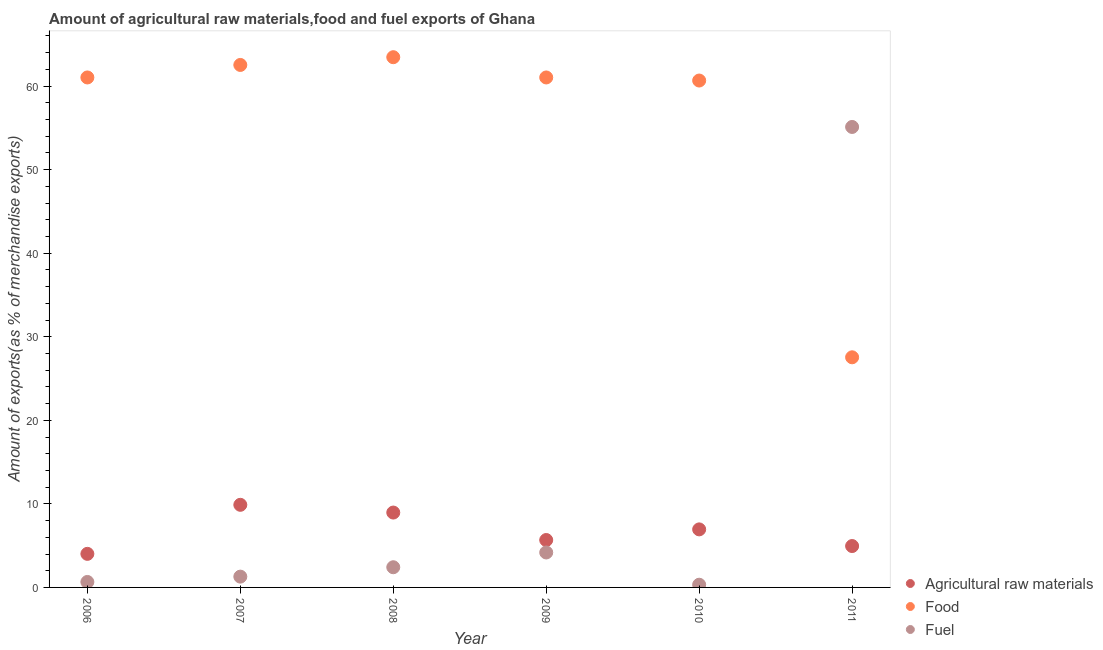What is the percentage of food exports in 2007?
Keep it short and to the point. 62.53. Across all years, what is the maximum percentage of raw materials exports?
Offer a terse response. 9.89. Across all years, what is the minimum percentage of food exports?
Your response must be concise. 27.54. In which year was the percentage of food exports minimum?
Offer a terse response. 2011. What is the total percentage of food exports in the graph?
Offer a very short reply. 336.28. What is the difference between the percentage of fuel exports in 2006 and that in 2011?
Provide a short and direct response. -54.46. What is the difference between the percentage of fuel exports in 2011 and the percentage of food exports in 2006?
Provide a short and direct response. -5.92. What is the average percentage of fuel exports per year?
Keep it short and to the point. 10.66. In the year 2011, what is the difference between the percentage of raw materials exports and percentage of food exports?
Provide a succinct answer. -22.59. What is the ratio of the percentage of food exports in 2008 to that in 2010?
Keep it short and to the point. 1.05. What is the difference between the highest and the second highest percentage of raw materials exports?
Ensure brevity in your answer.  0.93. What is the difference between the highest and the lowest percentage of raw materials exports?
Provide a short and direct response. 5.87. Is the sum of the percentage of raw materials exports in 2007 and 2009 greater than the maximum percentage of fuel exports across all years?
Keep it short and to the point. No. Does the percentage of food exports monotonically increase over the years?
Provide a succinct answer. No. Is the percentage of food exports strictly greater than the percentage of raw materials exports over the years?
Offer a very short reply. Yes. Is the percentage of fuel exports strictly less than the percentage of raw materials exports over the years?
Make the answer very short. No. How many years are there in the graph?
Your answer should be very brief. 6. Does the graph contain any zero values?
Your response must be concise. No. Does the graph contain grids?
Your response must be concise. No. Where does the legend appear in the graph?
Provide a short and direct response. Bottom right. How are the legend labels stacked?
Offer a very short reply. Vertical. What is the title of the graph?
Offer a very short reply. Amount of agricultural raw materials,food and fuel exports of Ghana. Does "Maunufacturing" appear as one of the legend labels in the graph?
Your response must be concise. No. What is the label or title of the X-axis?
Your answer should be very brief. Year. What is the label or title of the Y-axis?
Your answer should be very brief. Amount of exports(as % of merchandise exports). What is the Amount of exports(as % of merchandise exports) of Agricultural raw materials in 2006?
Ensure brevity in your answer.  4.02. What is the Amount of exports(as % of merchandise exports) of Food in 2006?
Ensure brevity in your answer.  61.04. What is the Amount of exports(as % of merchandise exports) of Fuel in 2006?
Your answer should be very brief. 0.65. What is the Amount of exports(as % of merchandise exports) in Agricultural raw materials in 2007?
Offer a very short reply. 9.89. What is the Amount of exports(as % of merchandise exports) of Food in 2007?
Make the answer very short. 62.53. What is the Amount of exports(as % of merchandise exports) in Fuel in 2007?
Your answer should be very brief. 1.29. What is the Amount of exports(as % of merchandise exports) of Agricultural raw materials in 2008?
Make the answer very short. 8.96. What is the Amount of exports(as % of merchandise exports) of Food in 2008?
Provide a short and direct response. 63.46. What is the Amount of exports(as % of merchandise exports) of Fuel in 2008?
Offer a terse response. 2.42. What is the Amount of exports(as % of merchandise exports) of Agricultural raw materials in 2009?
Ensure brevity in your answer.  5.67. What is the Amount of exports(as % of merchandise exports) in Food in 2009?
Your answer should be compact. 61.04. What is the Amount of exports(as % of merchandise exports) in Fuel in 2009?
Provide a succinct answer. 4.18. What is the Amount of exports(as % of merchandise exports) in Agricultural raw materials in 2010?
Provide a short and direct response. 6.95. What is the Amount of exports(as % of merchandise exports) of Food in 2010?
Offer a terse response. 60.67. What is the Amount of exports(as % of merchandise exports) in Fuel in 2010?
Your answer should be very brief. 0.32. What is the Amount of exports(as % of merchandise exports) in Agricultural raw materials in 2011?
Offer a very short reply. 4.95. What is the Amount of exports(as % of merchandise exports) of Food in 2011?
Give a very brief answer. 27.54. What is the Amount of exports(as % of merchandise exports) of Fuel in 2011?
Make the answer very short. 55.11. Across all years, what is the maximum Amount of exports(as % of merchandise exports) of Agricultural raw materials?
Make the answer very short. 9.89. Across all years, what is the maximum Amount of exports(as % of merchandise exports) in Food?
Provide a succinct answer. 63.46. Across all years, what is the maximum Amount of exports(as % of merchandise exports) of Fuel?
Your answer should be compact. 55.11. Across all years, what is the minimum Amount of exports(as % of merchandise exports) in Agricultural raw materials?
Provide a short and direct response. 4.02. Across all years, what is the minimum Amount of exports(as % of merchandise exports) of Food?
Make the answer very short. 27.54. Across all years, what is the minimum Amount of exports(as % of merchandise exports) of Fuel?
Give a very brief answer. 0.32. What is the total Amount of exports(as % of merchandise exports) in Agricultural raw materials in the graph?
Ensure brevity in your answer.  40.44. What is the total Amount of exports(as % of merchandise exports) in Food in the graph?
Ensure brevity in your answer.  336.28. What is the total Amount of exports(as % of merchandise exports) of Fuel in the graph?
Your answer should be very brief. 63.98. What is the difference between the Amount of exports(as % of merchandise exports) in Agricultural raw materials in 2006 and that in 2007?
Offer a very short reply. -5.87. What is the difference between the Amount of exports(as % of merchandise exports) of Food in 2006 and that in 2007?
Make the answer very short. -1.5. What is the difference between the Amount of exports(as % of merchandise exports) in Fuel in 2006 and that in 2007?
Ensure brevity in your answer.  -0.64. What is the difference between the Amount of exports(as % of merchandise exports) in Agricultural raw materials in 2006 and that in 2008?
Your answer should be very brief. -4.94. What is the difference between the Amount of exports(as % of merchandise exports) in Food in 2006 and that in 2008?
Provide a succinct answer. -2.42. What is the difference between the Amount of exports(as % of merchandise exports) of Fuel in 2006 and that in 2008?
Your response must be concise. -1.76. What is the difference between the Amount of exports(as % of merchandise exports) in Agricultural raw materials in 2006 and that in 2009?
Offer a terse response. -1.66. What is the difference between the Amount of exports(as % of merchandise exports) in Food in 2006 and that in 2009?
Keep it short and to the point. 0. What is the difference between the Amount of exports(as % of merchandise exports) of Fuel in 2006 and that in 2009?
Provide a short and direct response. -3.53. What is the difference between the Amount of exports(as % of merchandise exports) of Agricultural raw materials in 2006 and that in 2010?
Your answer should be very brief. -2.93. What is the difference between the Amount of exports(as % of merchandise exports) of Food in 2006 and that in 2010?
Keep it short and to the point. 0.37. What is the difference between the Amount of exports(as % of merchandise exports) of Fuel in 2006 and that in 2010?
Your answer should be very brief. 0.33. What is the difference between the Amount of exports(as % of merchandise exports) in Agricultural raw materials in 2006 and that in 2011?
Keep it short and to the point. -0.93. What is the difference between the Amount of exports(as % of merchandise exports) in Food in 2006 and that in 2011?
Offer a terse response. 33.49. What is the difference between the Amount of exports(as % of merchandise exports) of Fuel in 2006 and that in 2011?
Provide a succinct answer. -54.46. What is the difference between the Amount of exports(as % of merchandise exports) of Agricultural raw materials in 2007 and that in 2008?
Offer a terse response. 0.93. What is the difference between the Amount of exports(as % of merchandise exports) in Food in 2007 and that in 2008?
Provide a short and direct response. -0.93. What is the difference between the Amount of exports(as % of merchandise exports) of Fuel in 2007 and that in 2008?
Your answer should be compact. -1.12. What is the difference between the Amount of exports(as % of merchandise exports) in Agricultural raw materials in 2007 and that in 2009?
Your answer should be compact. 4.21. What is the difference between the Amount of exports(as % of merchandise exports) of Food in 2007 and that in 2009?
Your answer should be compact. 1.5. What is the difference between the Amount of exports(as % of merchandise exports) in Fuel in 2007 and that in 2009?
Give a very brief answer. -2.89. What is the difference between the Amount of exports(as % of merchandise exports) in Agricultural raw materials in 2007 and that in 2010?
Keep it short and to the point. 2.94. What is the difference between the Amount of exports(as % of merchandise exports) in Food in 2007 and that in 2010?
Your answer should be very brief. 1.87. What is the difference between the Amount of exports(as % of merchandise exports) in Fuel in 2007 and that in 2010?
Make the answer very short. 0.97. What is the difference between the Amount of exports(as % of merchandise exports) in Agricultural raw materials in 2007 and that in 2011?
Your answer should be very brief. 4.93. What is the difference between the Amount of exports(as % of merchandise exports) in Food in 2007 and that in 2011?
Provide a succinct answer. 34.99. What is the difference between the Amount of exports(as % of merchandise exports) in Fuel in 2007 and that in 2011?
Your response must be concise. -53.82. What is the difference between the Amount of exports(as % of merchandise exports) of Agricultural raw materials in 2008 and that in 2009?
Offer a very short reply. 3.29. What is the difference between the Amount of exports(as % of merchandise exports) in Food in 2008 and that in 2009?
Your response must be concise. 2.42. What is the difference between the Amount of exports(as % of merchandise exports) in Fuel in 2008 and that in 2009?
Give a very brief answer. -1.77. What is the difference between the Amount of exports(as % of merchandise exports) of Agricultural raw materials in 2008 and that in 2010?
Your response must be concise. 2.01. What is the difference between the Amount of exports(as % of merchandise exports) of Food in 2008 and that in 2010?
Your answer should be very brief. 2.79. What is the difference between the Amount of exports(as % of merchandise exports) of Fuel in 2008 and that in 2010?
Offer a very short reply. 2.09. What is the difference between the Amount of exports(as % of merchandise exports) in Agricultural raw materials in 2008 and that in 2011?
Your answer should be compact. 4.01. What is the difference between the Amount of exports(as % of merchandise exports) of Food in 2008 and that in 2011?
Give a very brief answer. 35.92. What is the difference between the Amount of exports(as % of merchandise exports) of Fuel in 2008 and that in 2011?
Provide a succinct answer. -52.7. What is the difference between the Amount of exports(as % of merchandise exports) of Agricultural raw materials in 2009 and that in 2010?
Your answer should be very brief. -1.27. What is the difference between the Amount of exports(as % of merchandise exports) of Food in 2009 and that in 2010?
Offer a terse response. 0.37. What is the difference between the Amount of exports(as % of merchandise exports) in Fuel in 2009 and that in 2010?
Provide a succinct answer. 3.86. What is the difference between the Amount of exports(as % of merchandise exports) of Agricultural raw materials in 2009 and that in 2011?
Provide a short and direct response. 0.72. What is the difference between the Amount of exports(as % of merchandise exports) in Food in 2009 and that in 2011?
Your answer should be compact. 33.49. What is the difference between the Amount of exports(as % of merchandise exports) of Fuel in 2009 and that in 2011?
Give a very brief answer. -50.93. What is the difference between the Amount of exports(as % of merchandise exports) in Agricultural raw materials in 2010 and that in 2011?
Offer a very short reply. 1.99. What is the difference between the Amount of exports(as % of merchandise exports) of Food in 2010 and that in 2011?
Give a very brief answer. 33.13. What is the difference between the Amount of exports(as % of merchandise exports) of Fuel in 2010 and that in 2011?
Give a very brief answer. -54.79. What is the difference between the Amount of exports(as % of merchandise exports) in Agricultural raw materials in 2006 and the Amount of exports(as % of merchandise exports) in Food in 2007?
Provide a succinct answer. -58.52. What is the difference between the Amount of exports(as % of merchandise exports) of Agricultural raw materials in 2006 and the Amount of exports(as % of merchandise exports) of Fuel in 2007?
Provide a succinct answer. 2.73. What is the difference between the Amount of exports(as % of merchandise exports) in Food in 2006 and the Amount of exports(as % of merchandise exports) in Fuel in 2007?
Keep it short and to the point. 59.74. What is the difference between the Amount of exports(as % of merchandise exports) of Agricultural raw materials in 2006 and the Amount of exports(as % of merchandise exports) of Food in 2008?
Offer a very short reply. -59.44. What is the difference between the Amount of exports(as % of merchandise exports) in Agricultural raw materials in 2006 and the Amount of exports(as % of merchandise exports) in Fuel in 2008?
Ensure brevity in your answer.  1.6. What is the difference between the Amount of exports(as % of merchandise exports) of Food in 2006 and the Amount of exports(as % of merchandise exports) of Fuel in 2008?
Offer a terse response. 58.62. What is the difference between the Amount of exports(as % of merchandise exports) in Agricultural raw materials in 2006 and the Amount of exports(as % of merchandise exports) in Food in 2009?
Your answer should be compact. -57.02. What is the difference between the Amount of exports(as % of merchandise exports) in Agricultural raw materials in 2006 and the Amount of exports(as % of merchandise exports) in Fuel in 2009?
Your answer should be very brief. -0.17. What is the difference between the Amount of exports(as % of merchandise exports) in Food in 2006 and the Amount of exports(as % of merchandise exports) in Fuel in 2009?
Make the answer very short. 56.85. What is the difference between the Amount of exports(as % of merchandise exports) in Agricultural raw materials in 2006 and the Amount of exports(as % of merchandise exports) in Food in 2010?
Make the answer very short. -56.65. What is the difference between the Amount of exports(as % of merchandise exports) in Agricultural raw materials in 2006 and the Amount of exports(as % of merchandise exports) in Fuel in 2010?
Give a very brief answer. 3.69. What is the difference between the Amount of exports(as % of merchandise exports) of Food in 2006 and the Amount of exports(as % of merchandise exports) of Fuel in 2010?
Your answer should be compact. 60.71. What is the difference between the Amount of exports(as % of merchandise exports) in Agricultural raw materials in 2006 and the Amount of exports(as % of merchandise exports) in Food in 2011?
Give a very brief answer. -23.53. What is the difference between the Amount of exports(as % of merchandise exports) in Agricultural raw materials in 2006 and the Amount of exports(as % of merchandise exports) in Fuel in 2011?
Give a very brief answer. -51.09. What is the difference between the Amount of exports(as % of merchandise exports) in Food in 2006 and the Amount of exports(as % of merchandise exports) in Fuel in 2011?
Provide a succinct answer. 5.92. What is the difference between the Amount of exports(as % of merchandise exports) in Agricultural raw materials in 2007 and the Amount of exports(as % of merchandise exports) in Food in 2008?
Keep it short and to the point. -53.57. What is the difference between the Amount of exports(as % of merchandise exports) of Agricultural raw materials in 2007 and the Amount of exports(as % of merchandise exports) of Fuel in 2008?
Keep it short and to the point. 7.47. What is the difference between the Amount of exports(as % of merchandise exports) of Food in 2007 and the Amount of exports(as % of merchandise exports) of Fuel in 2008?
Offer a very short reply. 60.12. What is the difference between the Amount of exports(as % of merchandise exports) in Agricultural raw materials in 2007 and the Amount of exports(as % of merchandise exports) in Food in 2009?
Your answer should be very brief. -51.15. What is the difference between the Amount of exports(as % of merchandise exports) of Agricultural raw materials in 2007 and the Amount of exports(as % of merchandise exports) of Fuel in 2009?
Provide a short and direct response. 5.7. What is the difference between the Amount of exports(as % of merchandise exports) in Food in 2007 and the Amount of exports(as % of merchandise exports) in Fuel in 2009?
Offer a very short reply. 58.35. What is the difference between the Amount of exports(as % of merchandise exports) in Agricultural raw materials in 2007 and the Amount of exports(as % of merchandise exports) in Food in 2010?
Provide a short and direct response. -50.78. What is the difference between the Amount of exports(as % of merchandise exports) in Agricultural raw materials in 2007 and the Amount of exports(as % of merchandise exports) in Fuel in 2010?
Offer a terse response. 9.56. What is the difference between the Amount of exports(as % of merchandise exports) of Food in 2007 and the Amount of exports(as % of merchandise exports) of Fuel in 2010?
Provide a succinct answer. 62.21. What is the difference between the Amount of exports(as % of merchandise exports) of Agricultural raw materials in 2007 and the Amount of exports(as % of merchandise exports) of Food in 2011?
Your response must be concise. -17.66. What is the difference between the Amount of exports(as % of merchandise exports) of Agricultural raw materials in 2007 and the Amount of exports(as % of merchandise exports) of Fuel in 2011?
Keep it short and to the point. -45.23. What is the difference between the Amount of exports(as % of merchandise exports) of Food in 2007 and the Amount of exports(as % of merchandise exports) of Fuel in 2011?
Give a very brief answer. 7.42. What is the difference between the Amount of exports(as % of merchandise exports) in Agricultural raw materials in 2008 and the Amount of exports(as % of merchandise exports) in Food in 2009?
Keep it short and to the point. -52.08. What is the difference between the Amount of exports(as % of merchandise exports) in Agricultural raw materials in 2008 and the Amount of exports(as % of merchandise exports) in Fuel in 2009?
Your response must be concise. 4.78. What is the difference between the Amount of exports(as % of merchandise exports) in Food in 2008 and the Amount of exports(as % of merchandise exports) in Fuel in 2009?
Provide a succinct answer. 59.28. What is the difference between the Amount of exports(as % of merchandise exports) of Agricultural raw materials in 2008 and the Amount of exports(as % of merchandise exports) of Food in 2010?
Your answer should be compact. -51.71. What is the difference between the Amount of exports(as % of merchandise exports) in Agricultural raw materials in 2008 and the Amount of exports(as % of merchandise exports) in Fuel in 2010?
Keep it short and to the point. 8.64. What is the difference between the Amount of exports(as % of merchandise exports) in Food in 2008 and the Amount of exports(as % of merchandise exports) in Fuel in 2010?
Your answer should be very brief. 63.14. What is the difference between the Amount of exports(as % of merchandise exports) of Agricultural raw materials in 2008 and the Amount of exports(as % of merchandise exports) of Food in 2011?
Provide a succinct answer. -18.58. What is the difference between the Amount of exports(as % of merchandise exports) in Agricultural raw materials in 2008 and the Amount of exports(as % of merchandise exports) in Fuel in 2011?
Your response must be concise. -46.15. What is the difference between the Amount of exports(as % of merchandise exports) of Food in 2008 and the Amount of exports(as % of merchandise exports) of Fuel in 2011?
Offer a very short reply. 8.35. What is the difference between the Amount of exports(as % of merchandise exports) in Agricultural raw materials in 2009 and the Amount of exports(as % of merchandise exports) in Food in 2010?
Your response must be concise. -54.99. What is the difference between the Amount of exports(as % of merchandise exports) in Agricultural raw materials in 2009 and the Amount of exports(as % of merchandise exports) in Fuel in 2010?
Give a very brief answer. 5.35. What is the difference between the Amount of exports(as % of merchandise exports) of Food in 2009 and the Amount of exports(as % of merchandise exports) of Fuel in 2010?
Make the answer very short. 60.71. What is the difference between the Amount of exports(as % of merchandise exports) of Agricultural raw materials in 2009 and the Amount of exports(as % of merchandise exports) of Food in 2011?
Give a very brief answer. -21.87. What is the difference between the Amount of exports(as % of merchandise exports) of Agricultural raw materials in 2009 and the Amount of exports(as % of merchandise exports) of Fuel in 2011?
Provide a succinct answer. -49.44. What is the difference between the Amount of exports(as % of merchandise exports) of Food in 2009 and the Amount of exports(as % of merchandise exports) of Fuel in 2011?
Ensure brevity in your answer.  5.92. What is the difference between the Amount of exports(as % of merchandise exports) in Agricultural raw materials in 2010 and the Amount of exports(as % of merchandise exports) in Food in 2011?
Provide a short and direct response. -20.6. What is the difference between the Amount of exports(as % of merchandise exports) of Agricultural raw materials in 2010 and the Amount of exports(as % of merchandise exports) of Fuel in 2011?
Give a very brief answer. -48.17. What is the difference between the Amount of exports(as % of merchandise exports) in Food in 2010 and the Amount of exports(as % of merchandise exports) in Fuel in 2011?
Make the answer very short. 5.56. What is the average Amount of exports(as % of merchandise exports) of Agricultural raw materials per year?
Provide a short and direct response. 6.74. What is the average Amount of exports(as % of merchandise exports) of Food per year?
Offer a terse response. 56.05. What is the average Amount of exports(as % of merchandise exports) of Fuel per year?
Offer a very short reply. 10.66. In the year 2006, what is the difference between the Amount of exports(as % of merchandise exports) in Agricultural raw materials and Amount of exports(as % of merchandise exports) in Food?
Provide a short and direct response. -57.02. In the year 2006, what is the difference between the Amount of exports(as % of merchandise exports) of Agricultural raw materials and Amount of exports(as % of merchandise exports) of Fuel?
Ensure brevity in your answer.  3.36. In the year 2006, what is the difference between the Amount of exports(as % of merchandise exports) of Food and Amount of exports(as % of merchandise exports) of Fuel?
Your answer should be very brief. 60.38. In the year 2007, what is the difference between the Amount of exports(as % of merchandise exports) of Agricultural raw materials and Amount of exports(as % of merchandise exports) of Food?
Your answer should be very brief. -52.65. In the year 2007, what is the difference between the Amount of exports(as % of merchandise exports) of Agricultural raw materials and Amount of exports(as % of merchandise exports) of Fuel?
Your answer should be compact. 8.6. In the year 2007, what is the difference between the Amount of exports(as % of merchandise exports) of Food and Amount of exports(as % of merchandise exports) of Fuel?
Your answer should be very brief. 61.24. In the year 2008, what is the difference between the Amount of exports(as % of merchandise exports) of Agricultural raw materials and Amount of exports(as % of merchandise exports) of Food?
Make the answer very short. -54.5. In the year 2008, what is the difference between the Amount of exports(as % of merchandise exports) in Agricultural raw materials and Amount of exports(as % of merchandise exports) in Fuel?
Give a very brief answer. 6.55. In the year 2008, what is the difference between the Amount of exports(as % of merchandise exports) of Food and Amount of exports(as % of merchandise exports) of Fuel?
Offer a very short reply. 61.05. In the year 2009, what is the difference between the Amount of exports(as % of merchandise exports) in Agricultural raw materials and Amount of exports(as % of merchandise exports) in Food?
Give a very brief answer. -55.36. In the year 2009, what is the difference between the Amount of exports(as % of merchandise exports) of Agricultural raw materials and Amount of exports(as % of merchandise exports) of Fuel?
Your answer should be very brief. 1.49. In the year 2009, what is the difference between the Amount of exports(as % of merchandise exports) of Food and Amount of exports(as % of merchandise exports) of Fuel?
Your answer should be compact. 56.85. In the year 2010, what is the difference between the Amount of exports(as % of merchandise exports) of Agricultural raw materials and Amount of exports(as % of merchandise exports) of Food?
Keep it short and to the point. -53.72. In the year 2010, what is the difference between the Amount of exports(as % of merchandise exports) in Agricultural raw materials and Amount of exports(as % of merchandise exports) in Fuel?
Offer a terse response. 6.62. In the year 2010, what is the difference between the Amount of exports(as % of merchandise exports) of Food and Amount of exports(as % of merchandise exports) of Fuel?
Offer a terse response. 60.34. In the year 2011, what is the difference between the Amount of exports(as % of merchandise exports) of Agricultural raw materials and Amount of exports(as % of merchandise exports) of Food?
Your answer should be compact. -22.59. In the year 2011, what is the difference between the Amount of exports(as % of merchandise exports) in Agricultural raw materials and Amount of exports(as % of merchandise exports) in Fuel?
Your answer should be very brief. -50.16. In the year 2011, what is the difference between the Amount of exports(as % of merchandise exports) in Food and Amount of exports(as % of merchandise exports) in Fuel?
Make the answer very short. -27.57. What is the ratio of the Amount of exports(as % of merchandise exports) of Agricultural raw materials in 2006 to that in 2007?
Provide a succinct answer. 0.41. What is the ratio of the Amount of exports(as % of merchandise exports) in Food in 2006 to that in 2007?
Keep it short and to the point. 0.98. What is the ratio of the Amount of exports(as % of merchandise exports) of Fuel in 2006 to that in 2007?
Your answer should be compact. 0.51. What is the ratio of the Amount of exports(as % of merchandise exports) of Agricultural raw materials in 2006 to that in 2008?
Offer a very short reply. 0.45. What is the ratio of the Amount of exports(as % of merchandise exports) in Food in 2006 to that in 2008?
Keep it short and to the point. 0.96. What is the ratio of the Amount of exports(as % of merchandise exports) of Fuel in 2006 to that in 2008?
Your response must be concise. 0.27. What is the ratio of the Amount of exports(as % of merchandise exports) in Agricultural raw materials in 2006 to that in 2009?
Give a very brief answer. 0.71. What is the ratio of the Amount of exports(as % of merchandise exports) in Food in 2006 to that in 2009?
Provide a short and direct response. 1. What is the ratio of the Amount of exports(as % of merchandise exports) in Fuel in 2006 to that in 2009?
Your response must be concise. 0.16. What is the ratio of the Amount of exports(as % of merchandise exports) of Agricultural raw materials in 2006 to that in 2010?
Make the answer very short. 0.58. What is the ratio of the Amount of exports(as % of merchandise exports) in Fuel in 2006 to that in 2010?
Offer a terse response. 2.02. What is the ratio of the Amount of exports(as % of merchandise exports) in Agricultural raw materials in 2006 to that in 2011?
Offer a terse response. 0.81. What is the ratio of the Amount of exports(as % of merchandise exports) of Food in 2006 to that in 2011?
Your answer should be compact. 2.22. What is the ratio of the Amount of exports(as % of merchandise exports) of Fuel in 2006 to that in 2011?
Make the answer very short. 0.01. What is the ratio of the Amount of exports(as % of merchandise exports) of Agricultural raw materials in 2007 to that in 2008?
Your response must be concise. 1.1. What is the ratio of the Amount of exports(as % of merchandise exports) in Food in 2007 to that in 2008?
Keep it short and to the point. 0.99. What is the ratio of the Amount of exports(as % of merchandise exports) of Fuel in 2007 to that in 2008?
Your answer should be compact. 0.54. What is the ratio of the Amount of exports(as % of merchandise exports) in Agricultural raw materials in 2007 to that in 2009?
Your answer should be compact. 1.74. What is the ratio of the Amount of exports(as % of merchandise exports) in Food in 2007 to that in 2009?
Your answer should be compact. 1.02. What is the ratio of the Amount of exports(as % of merchandise exports) of Fuel in 2007 to that in 2009?
Provide a short and direct response. 0.31. What is the ratio of the Amount of exports(as % of merchandise exports) in Agricultural raw materials in 2007 to that in 2010?
Provide a short and direct response. 1.42. What is the ratio of the Amount of exports(as % of merchandise exports) in Food in 2007 to that in 2010?
Your answer should be compact. 1.03. What is the ratio of the Amount of exports(as % of merchandise exports) of Fuel in 2007 to that in 2010?
Provide a short and direct response. 3.99. What is the ratio of the Amount of exports(as % of merchandise exports) of Agricultural raw materials in 2007 to that in 2011?
Make the answer very short. 2. What is the ratio of the Amount of exports(as % of merchandise exports) of Food in 2007 to that in 2011?
Your response must be concise. 2.27. What is the ratio of the Amount of exports(as % of merchandise exports) in Fuel in 2007 to that in 2011?
Provide a succinct answer. 0.02. What is the ratio of the Amount of exports(as % of merchandise exports) of Agricultural raw materials in 2008 to that in 2009?
Your answer should be very brief. 1.58. What is the ratio of the Amount of exports(as % of merchandise exports) in Food in 2008 to that in 2009?
Keep it short and to the point. 1.04. What is the ratio of the Amount of exports(as % of merchandise exports) of Fuel in 2008 to that in 2009?
Your answer should be compact. 0.58. What is the ratio of the Amount of exports(as % of merchandise exports) in Agricultural raw materials in 2008 to that in 2010?
Provide a succinct answer. 1.29. What is the ratio of the Amount of exports(as % of merchandise exports) of Food in 2008 to that in 2010?
Keep it short and to the point. 1.05. What is the ratio of the Amount of exports(as % of merchandise exports) in Fuel in 2008 to that in 2010?
Offer a very short reply. 7.47. What is the ratio of the Amount of exports(as % of merchandise exports) of Agricultural raw materials in 2008 to that in 2011?
Offer a very short reply. 1.81. What is the ratio of the Amount of exports(as % of merchandise exports) of Food in 2008 to that in 2011?
Offer a very short reply. 2.3. What is the ratio of the Amount of exports(as % of merchandise exports) in Fuel in 2008 to that in 2011?
Give a very brief answer. 0.04. What is the ratio of the Amount of exports(as % of merchandise exports) in Agricultural raw materials in 2009 to that in 2010?
Provide a succinct answer. 0.82. What is the ratio of the Amount of exports(as % of merchandise exports) in Fuel in 2009 to that in 2010?
Make the answer very short. 12.93. What is the ratio of the Amount of exports(as % of merchandise exports) of Agricultural raw materials in 2009 to that in 2011?
Provide a succinct answer. 1.15. What is the ratio of the Amount of exports(as % of merchandise exports) in Food in 2009 to that in 2011?
Your answer should be compact. 2.22. What is the ratio of the Amount of exports(as % of merchandise exports) in Fuel in 2009 to that in 2011?
Provide a succinct answer. 0.08. What is the ratio of the Amount of exports(as % of merchandise exports) in Agricultural raw materials in 2010 to that in 2011?
Your answer should be very brief. 1.4. What is the ratio of the Amount of exports(as % of merchandise exports) of Food in 2010 to that in 2011?
Keep it short and to the point. 2.2. What is the ratio of the Amount of exports(as % of merchandise exports) of Fuel in 2010 to that in 2011?
Your answer should be compact. 0.01. What is the difference between the highest and the second highest Amount of exports(as % of merchandise exports) in Agricultural raw materials?
Your answer should be compact. 0.93. What is the difference between the highest and the second highest Amount of exports(as % of merchandise exports) of Food?
Give a very brief answer. 0.93. What is the difference between the highest and the second highest Amount of exports(as % of merchandise exports) in Fuel?
Your response must be concise. 50.93. What is the difference between the highest and the lowest Amount of exports(as % of merchandise exports) in Agricultural raw materials?
Provide a succinct answer. 5.87. What is the difference between the highest and the lowest Amount of exports(as % of merchandise exports) in Food?
Provide a short and direct response. 35.92. What is the difference between the highest and the lowest Amount of exports(as % of merchandise exports) in Fuel?
Offer a very short reply. 54.79. 